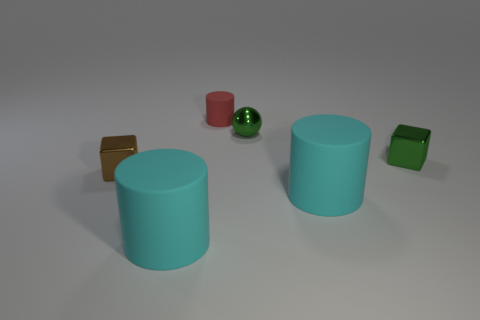Are there fewer cubes that are in front of the small brown cube than big brown metal cylinders?
Offer a terse response. No. What is the material of the cylinder that is the same size as the brown thing?
Ensure brevity in your answer.  Rubber. What is the size of the rubber object that is left of the small metallic sphere and in front of the red matte thing?
Your response must be concise. Large. There is a green thing that is the same shape as the tiny brown thing; what is its size?
Offer a terse response. Small. What number of objects are either small gray metallic cylinders or cyan cylinders on the left side of the metal sphere?
Your answer should be compact. 1. There is a red rubber object; what shape is it?
Make the answer very short. Cylinder. There is a big object right of the ball that is in front of the tiny red cylinder; what is its shape?
Keep it short and to the point. Cylinder. There is a object that is the same color as the sphere; what material is it?
Make the answer very short. Metal. There is a small ball that is the same material as the green cube; what is its color?
Make the answer very short. Green. Do the large rubber cylinder that is on the left side of the tiny red thing and the tiny metal object that is to the left of the red rubber object have the same color?
Offer a terse response. No. 